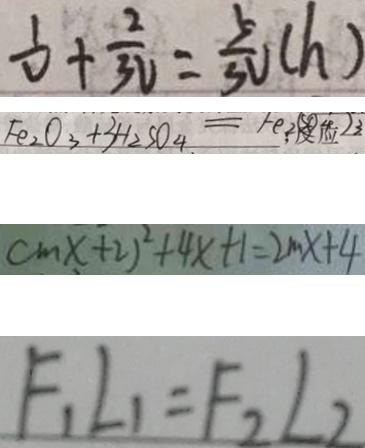Convert formula to latex. <formula><loc_0><loc_0><loc_500><loc_500>\frac { 1 } { V } + \frac { 2 } { 3 V } = \frac { 5 } { 3 V } ( h ) 
 F e _ { 2 } O _ { 3 } + 3 H _ { 2 } S O _ { 4 } = F e _ { 2 } S O _ { 4 } ) 3 
 c m x + 2 ) ^ { 2 } + 4 x + 1 = 2 m x + 4 
 F _ { 1 } L _ { 1 } = F _ { 2 } L _ { 2 }</formula> 